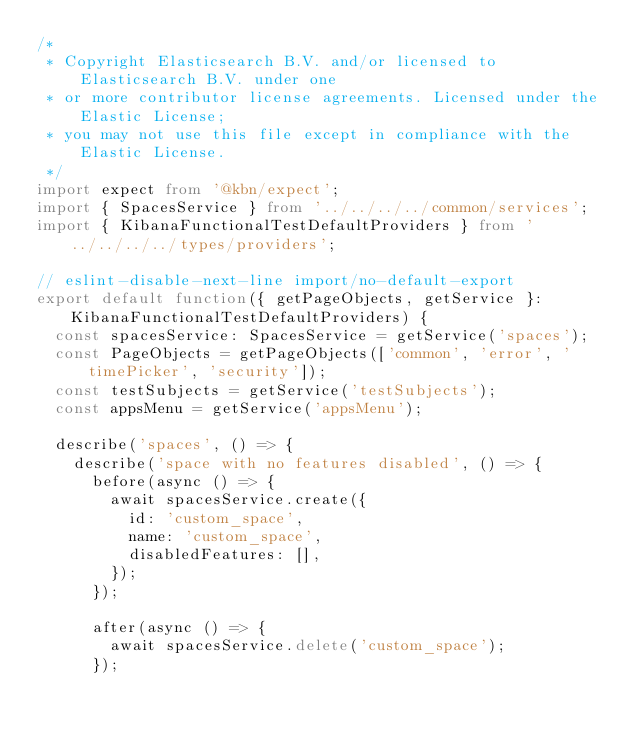<code> <loc_0><loc_0><loc_500><loc_500><_TypeScript_>/*
 * Copyright Elasticsearch B.V. and/or licensed to Elasticsearch B.V. under one
 * or more contributor license agreements. Licensed under the Elastic License;
 * you may not use this file except in compliance with the Elastic License.
 */
import expect from '@kbn/expect';
import { SpacesService } from '../../../../common/services';
import { KibanaFunctionalTestDefaultProviders } from '../../../../types/providers';

// eslint-disable-next-line import/no-default-export
export default function({ getPageObjects, getService }: KibanaFunctionalTestDefaultProviders) {
  const spacesService: SpacesService = getService('spaces');
  const PageObjects = getPageObjects(['common', 'error', 'timePicker', 'security']);
  const testSubjects = getService('testSubjects');
  const appsMenu = getService('appsMenu');

  describe('spaces', () => {
    describe('space with no features disabled', () => {
      before(async () => {
        await spacesService.create({
          id: 'custom_space',
          name: 'custom_space',
          disabledFeatures: [],
        });
      });

      after(async () => {
        await spacesService.delete('custom_space');
      });
</code> 